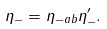<formula> <loc_0><loc_0><loc_500><loc_500>\eta _ { - } = \eta _ { - a b } \eta ^ { \prime } _ { - } .</formula> 